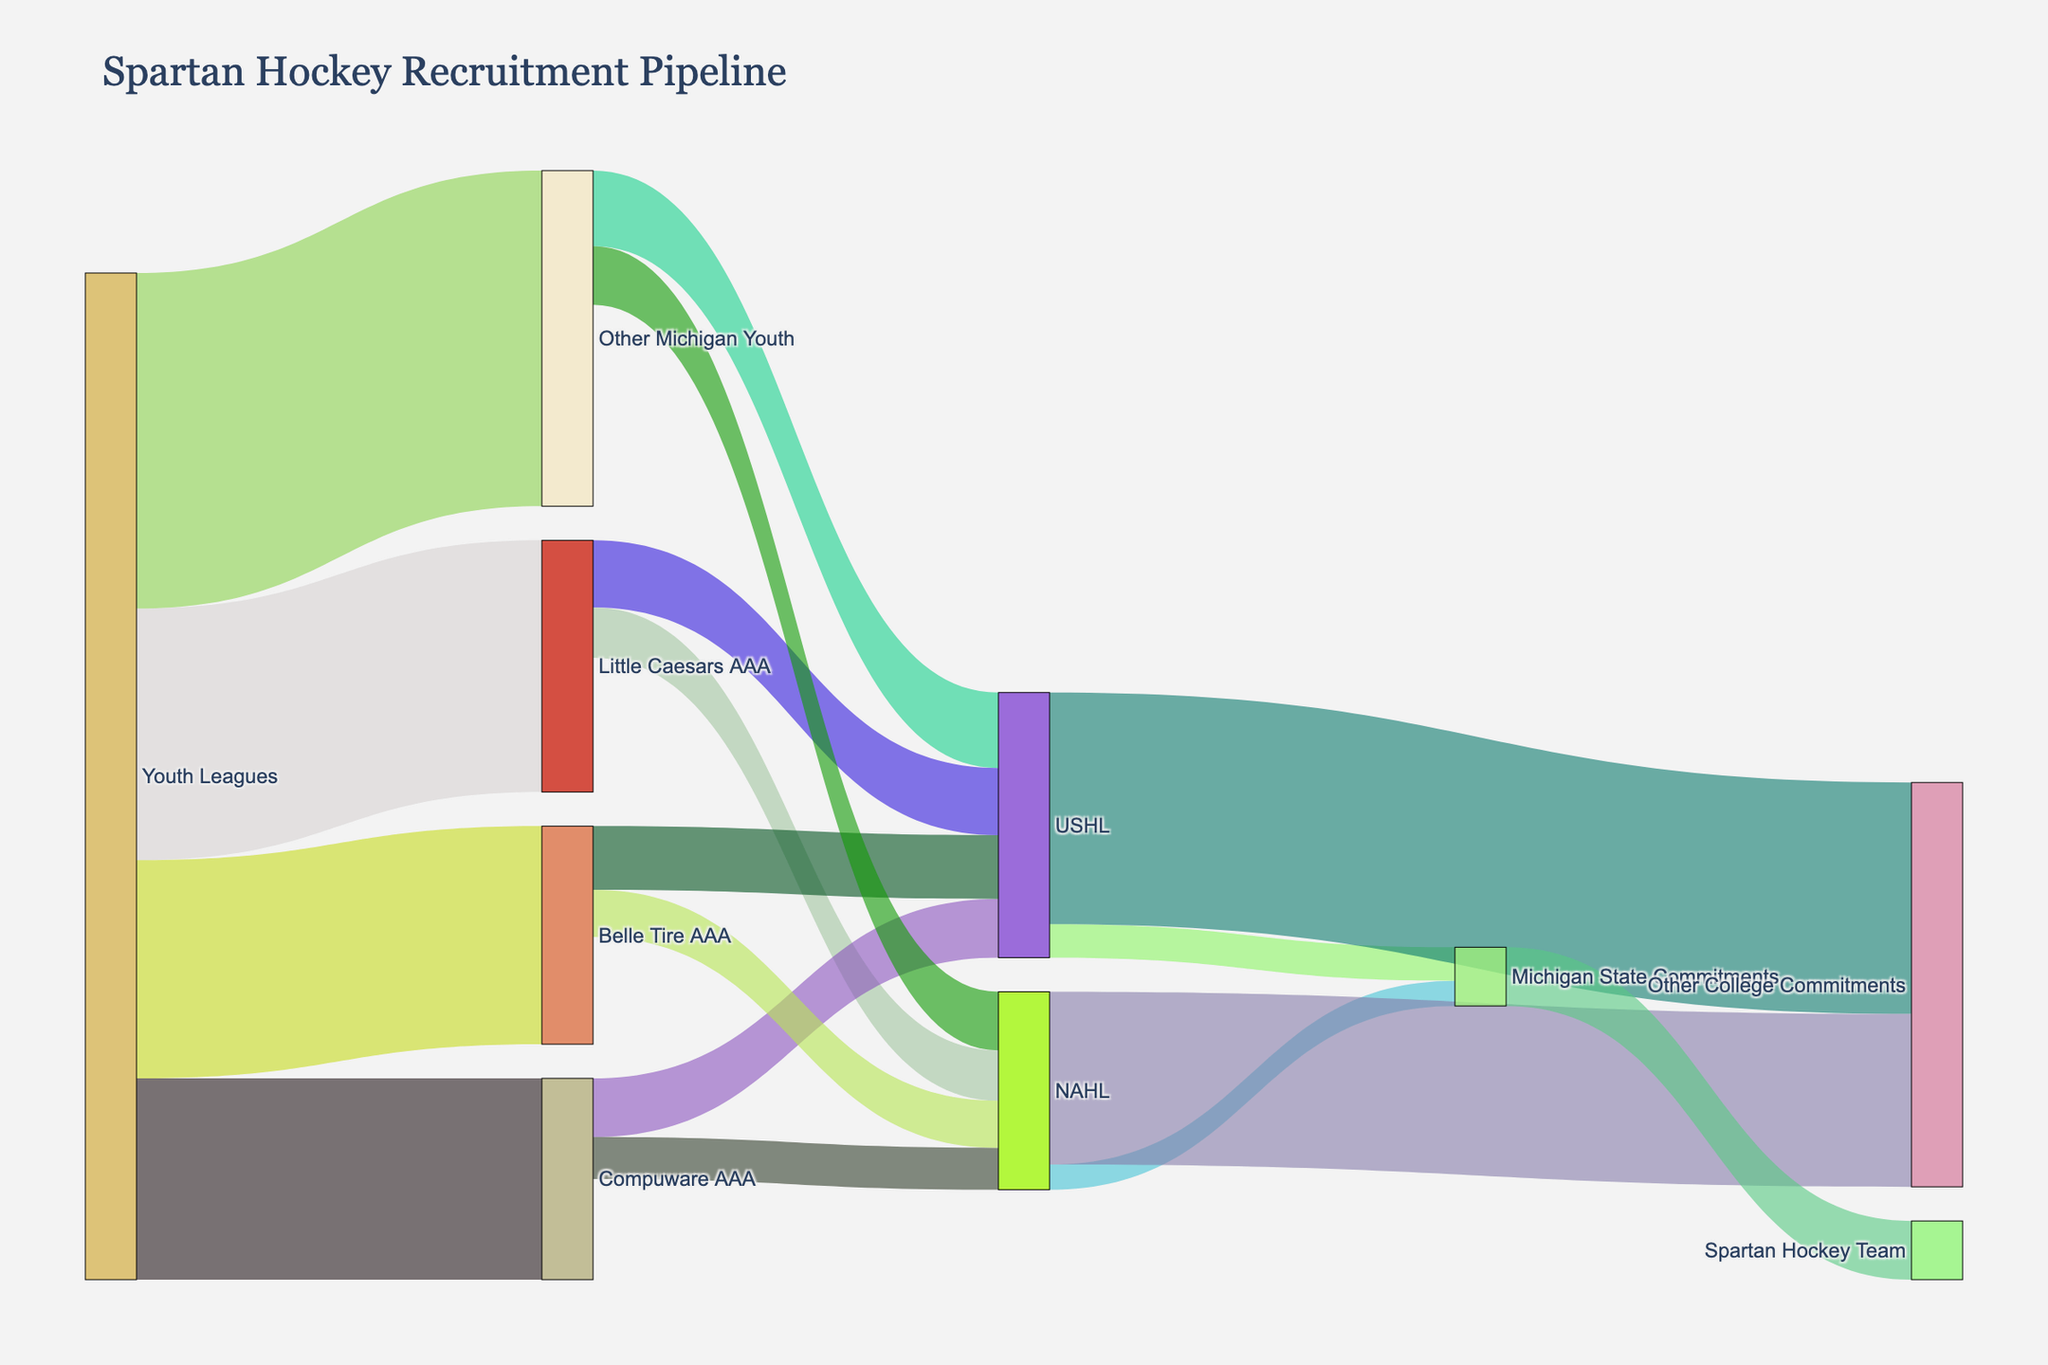What is the title of the Sankey diagram? The title of the diagram is displayed prominently at the top of the figure.
Answer: Spartan Hockey Recruitment Pipeline How many players come from Little Caesars AAA? Look at the nodes connected to "Little Caesars AAA" and sum their values.
Answer: 70 Which youth league has the most players moving to higher levels? Examine the values of the flows from all "Youth Leagues" to their targets and identify the highest.
Answer: Other Michigan Youth From which league does the majority of Michigan State Commitments come from? Compare the flows leading to "Michigan State Commitments" from USHL and NAHL. The higher flow indicates the majority source.
Answer: USHL What is the total number of players moving from Youth Leagues to Higher levels? Sum all the values leaving "Youth Leagues" nodes.
Answer: 600 How many total players commit to colleges, whether to Michigan State or other colleges? Add the values leading to "Michigan State Commitments" and "Other College Commitments" nodes.
Answer: 276 Which league sends more players to the NAHL, Little Caesars AAA or Belle Tire AAA? Compare the flow values from "Little Caesars AAA" and "Belle Tire AAA" leading to "NAHL".
Answer: Belle Tire AAA How many players in total reach the Spartan hockey team? Check the flow value leading to "Spartan Hockey Team".
Answer: 35 What proportion of USHL players commit to Michigan State compared to Other Colleges? Calculate the ratio of the flow value leading to "Michigan State Commitments" to the total flow value from USHL to colleges.
Answer: 20/158 What percentage of recruits from Other Michigan Youth end up committing to colleges? Sum the flow values from "Other Michigan Youth" leading to any college-related nodes, then divide by the total value from "Other Michigan Youth" and multiply by 100.
Answer: (45 + 35) / 200 * 100 = 40% 